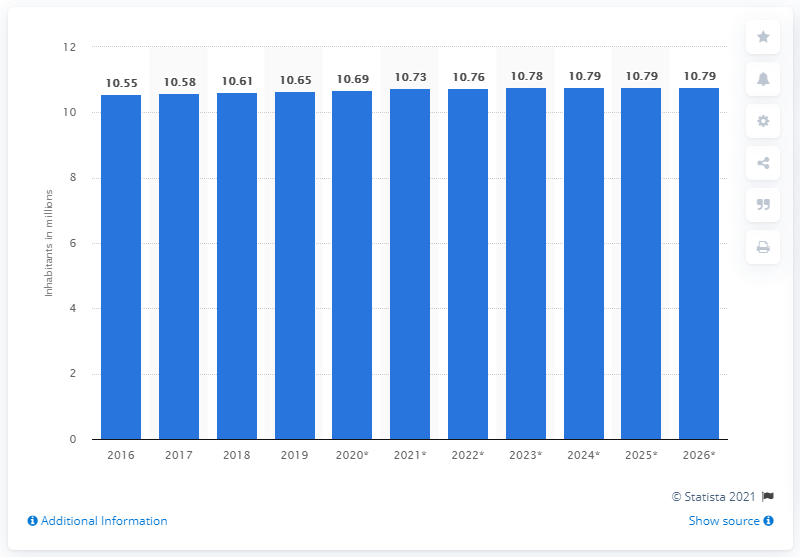Indicate a few pertinent items in this graphic. In 2019, the population of the Czech Republic was 10.73 million. 